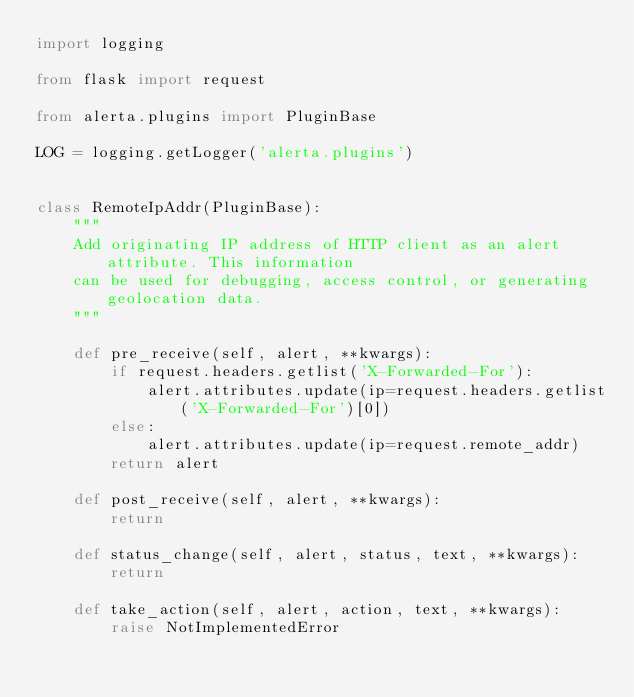Convert code to text. <code><loc_0><loc_0><loc_500><loc_500><_Python_>import logging

from flask import request

from alerta.plugins import PluginBase

LOG = logging.getLogger('alerta.plugins')


class RemoteIpAddr(PluginBase):
    """
    Add originating IP address of HTTP client as an alert attribute. This information
    can be used for debugging, access control, or generating geolocation data.
    """

    def pre_receive(self, alert, **kwargs):
        if request.headers.getlist('X-Forwarded-For'):
            alert.attributes.update(ip=request.headers.getlist('X-Forwarded-For')[0])
        else:
            alert.attributes.update(ip=request.remote_addr)
        return alert

    def post_receive(self, alert, **kwargs):
        return

    def status_change(self, alert, status, text, **kwargs):
        return

    def take_action(self, alert, action, text, **kwargs):
        raise NotImplementedError
</code> 